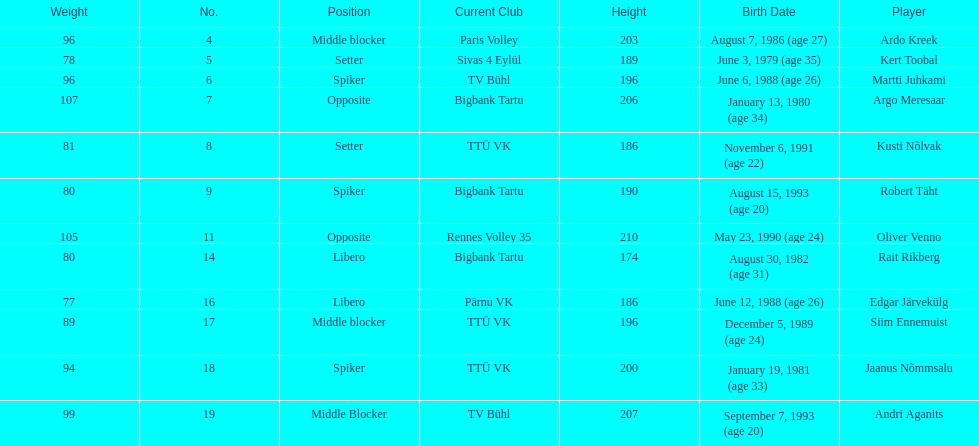How many players were born before 1988? 5. 